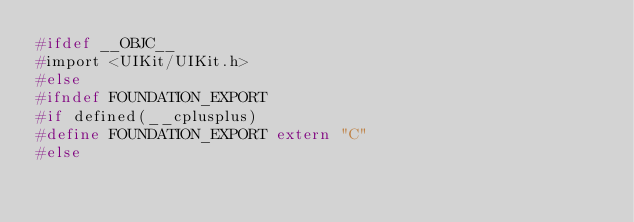Convert code to text. <code><loc_0><loc_0><loc_500><loc_500><_C_>#ifdef __OBJC__
#import <UIKit/UIKit.h>
#else
#ifndef FOUNDATION_EXPORT
#if defined(__cplusplus)
#define FOUNDATION_EXPORT extern "C"
#else</code> 